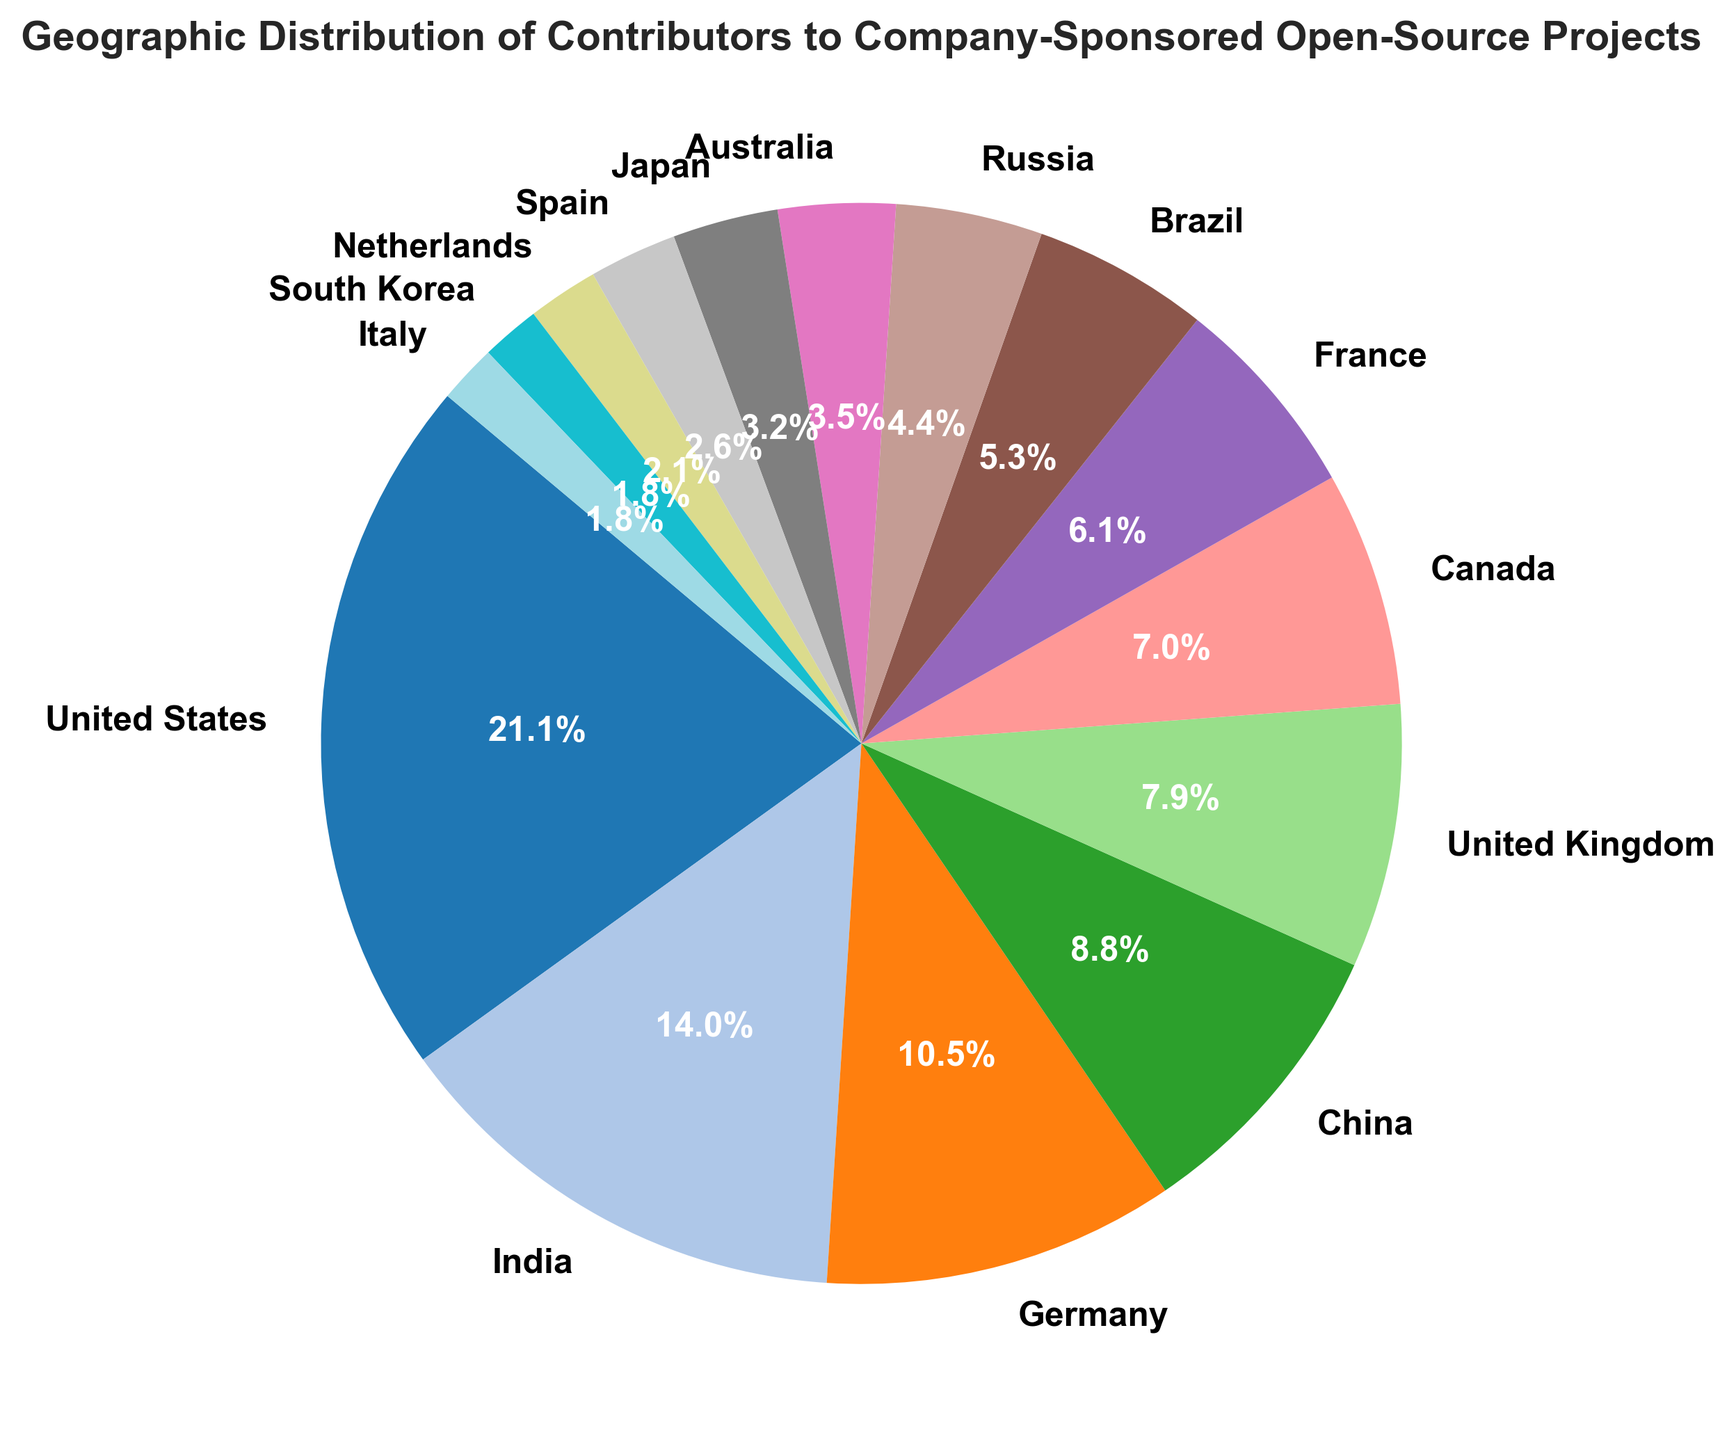What percentage of contributors are from the United States? The United States has a slice of the pie chart labeled with its percentage. Directly from the figure, the label on the slice for the United States says 27.4%.
Answer: 27.4% Which country has the second-highest number of contributors? The second-largest slice after the United States is labeled as India. Comparing the sizes of all slices confirms that India's slice is the second largest.
Answer: India How many more contributors does Germany have compared to Australia? Germany's slice represents 60 contributors, while Australia's slice represents 20 contributors. The difference is calculated as 60 - 20.
Answer: 40 Between Brazil and Japan, which country has more contributors and by how many? Brazil has 30 contributors, and Japan has 18 contributors. Subtract the number of contributors in Japan from Brazil to find the difference.
Answer: Brazil, by 12 What is the combined percentage of contributors from France, Brazil, and Russia? France has 7.1%, Brazil has 6.8%, and Russia has 5.7%. Summing these percentages gives 7.1 + 6.8 + 5.7 = 19.6%.
Answer: 19.6% Which countries have fewer than 15 contributors? The slices labeled for countries with fewer than 15 contributors are Japan (18), Spain (15), Netherlands (12), South Korea (10), and Italy (10). The question specifies fewer than 15, so exclude Japan and Spain.
Answer: Netherlands, South Korea, Italy If you sum the contributors from China and the United Kingdom, how many contributors does that make? China has 50 contributors, and the United Kingdom has 45 contributors. Their sum is 50 + 45.
Answer: 95 What is the largest difference in the number of contributors between any two neighboring countries on the pie chart? Identify neighboring slices with the most significant visual size difference. The largest difference visually is between the United States (120) and India (80). The absolute difference is 120 - 80.
Answer: 40 